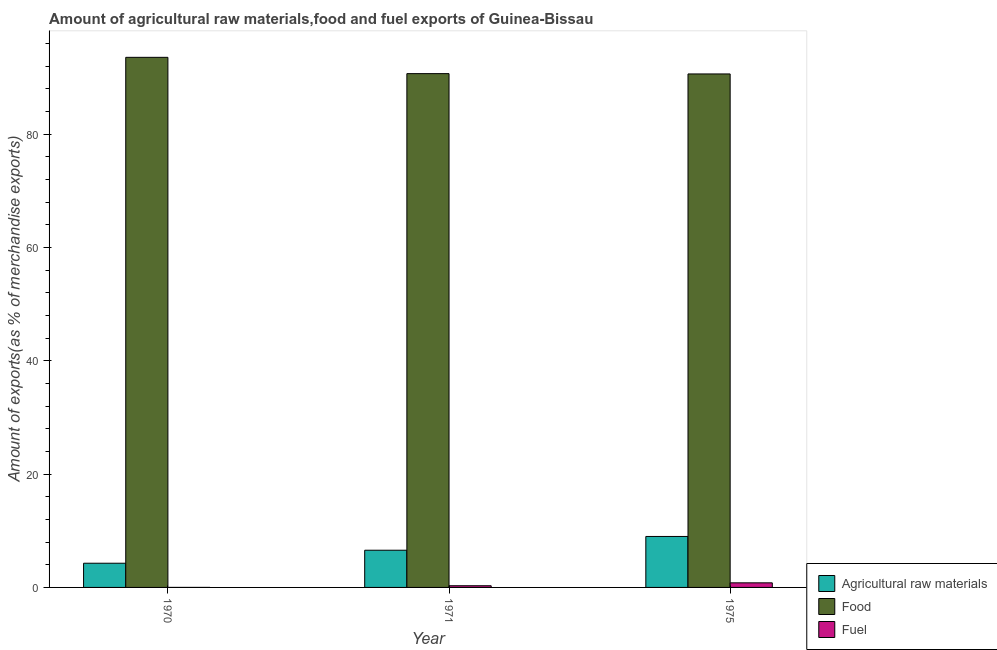How many bars are there on the 1st tick from the right?
Your answer should be very brief. 3. What is the label of the 1st group of bars from the left?
Provide a short and direct response. 1970. In how many cases, is the number of bars for a given year not equal to the number of legend labels?
Keep it short and to the point. 0. What is the percentage of food exports in 1971?
Your response must be concise. 90.71. Across all years, what is the maximum percentage of food exports?
Give a very brief answer. 93.59. Across all years, what is the minimum percentage of food exports?
Give a very brief answer. 90.65. In which year was the percentage of raw materials exports maximum?
Provide a short and direct response. 1975. In which year was the percentage of fuel exports minimum?
Give a very brief answer. 1970. What is the total percentage of fuel exports in the graph?
Your answer should be compact. 1.11. What is the difference between the percentage of raw materials exports in 1970 and that in 1971?
Make the answer very short. -2.29. What is the difference between the percentage of fuel exports in 1975 and the percentage of raw materials exports in 1970?
Ensure brevity in your answer.  0.81. What is the average percentage of food exports per year?
Keep it short and to the point. 91.65. In how many years, is the percentage of food exports greater than 12 %?
Keep it short and to the point. 3. What is the ratio of the percentage of fuel exports in 1970 to that in 1975?
Your answer should be very brief. 0. Is the difference between the percentage of fuel exports in 1970 and 1971 greater than the difference between the percentage of food exports in 1970 and 1971?
Provide a succinct answer. No. What is the difference between the highest and the second highest percentage of food exports?
Ensure brevity in your answer.  2.88. What is the difference between the highest and the lowest percentage of fuel exports?
Ensure brevity in your answer.  0.81. In how many years, is the percentage of raw materials exports greater than the average percentage of raw materials exports taken over all years?
Give a very brief answer. 1. What does the 2nd bar from the left in 1971 represents?
Offer a very short reply. Food. What does the 1st bar from the right in 1971 represents?
Make the answer very short. Fuel. Is it the case that in every year, the sum of the percentage of raw materials exports and percentage of food exports is greater than the percentage of fuel exports?
Your answer should be compact. Yes. How many bars are there?
Offer a very short reply. 9. Are all the bars in the graph horizontal?
Your answer should be very brief. No. What is the difference between two consecutive major ticks on the Y-axis?
Keep it short and to the point. 20. Are the values on the major ticks of Y-axis written in scientific E-notation?
Your answer should be compact. No. Does the graph contain any zero values?
Ensure brevity in your answer.  No. Does the graph contain grids?
Provide a succinct answer. No. Where does the legend appear in the graph?
Your answer should be compact. Bottom right. How many legend labels are there?
Your response must be concise. 3. How are the legend labels stacked?
Your response must be concise. Vertical. What is the title of the graph?
Your answer should be very brief. Amount of agricultural raw materials,food and fuel exports of Guinea-Bissau. What is the label or title of the X-axis?
Provide a succinct answer. Year. What is the label or title of the Y-axis?
Your answer should be very brief. Amount of exports(as % of merchandise exports). What is the Amount of exports(as % of merchandise exports) in Agricultural raw materials in 1970?
Keep it short and to the point. 4.27. What is the Amount of exports(as % of merchandise exports) in Food in 1970?
Offer a terse response. 93.59. What is the Amount of exports(as % of merchandise exports) of Fuel in 1970?
Offer a terse response. 0. What is the Amount of exports(as % of merchandise exports) of Agricultural raw materials in 1971?
Ensure brevity in your answer.  6.57. What is the Amount of exports(as % of merchandise exports) in Food in 1971?
Your answer should be compact. 90.71. What is the Amount of exports(as % of merchandise exports) in Fuel in 1971?
Give a very brief answer. 0.3. What is the Amount of exports(as % of merchandise exports) in Agricultural raw materials in 1975?
Provide a short and direct response. 9. What is the Amount of exports(as % of merchandise exports) in Food in 1975?
Offer a very short reply. 90.65. What is the Amount of exports(as % of merchandise exports) of Fuel in 1975?
Provide a succinct answer. 0.81. Across all years, what is the maximum Amount of exports(as % of merchandise exports) of Agricultural raw materials?
Make the answer very short. 9. Across all years, what is the maximum Amount of exports(as % of merchandise exports) in Food?
Your answer should be compact. 93.59. Across all years, what is the maximum Amount of exports(as % of merchandise exports) of Fuel?
Offer a very short reply. 0.81. Across all years, what is the minimum Amount of exports(as % of merchandise exports) in Agricultural raw materials?
Provide a short and direct response. 4.27. Across all years, what is the minimum Amount of exports(as % of merchandise exports) in Food?
Keep it short and to the point. 90.65. Across all years, what is the minimum Amount of exports(as % of merchandise exports) in Fuel?
Make the answer very short. 0. What is the total Amount of exports(as % of merchandise exports) in Agricultural raw materials in the graph?
Make the answer very short. 19.84. What is the total Amount of exports(as % of merchandise exports) in Food in the graph?
Offer a very short reply. 274.95. What is the total Amount of exports(as % of merchandise exports) in Fuel in the graph?
Provide a short and direct response. 1.11. What is the difference between the Amount of exports(as % of merchandise exports) in Agricultural raw materials in 1970 and that in 1971?
Provide a succinct answer. -2.29. What is the difference between the Amount of exports(as % of merchandise exports) in Food in 1970 and that in 1971?
Your response must be concise. 2.88. What is the difference between the Amount of exports(as % of merchandise exports) of Fuel in 1970 and that in 1971?
Make the answer very short. -0.3. What is the difference between the Amount of exports(as % of merchandise exports) of Agricultural raw materials in 1970 and that in 1975?
Your answer should be compact. -4.73. What is the difference between the Amount of exports(as % of merchandise exports) in Food in 1970 and that in 1975?
Offer a terse response. 2.93. What is the difference between the Amount of exports(as % of merchandise exports) of Fuel in 1970 and that in 1975?
Your answer should be very brief. -0.81. What is the difference between the Amount of exports(as % of merchandise exports) of Agricultural raw materials in 1971 and that in 1975?
Your response must be concise. -2.43. What is the difference between the Amount of exports(as % of merchandise exports) in Food in 1971 and that in 1975?
Keep it short and to the point. 0.06. What is the difference between the Amount of exports(as % of merchandise exports) in Fuel in 1971 and that in 1975?
Make the answer very short. -0.51. What is the difference between the Amount of exports(as % of merchandise exports) in Agricultural raw materials in 1970 and the Amount of exports(as % of merchandise exports) in Food in 1971?
Your answer should be compact. -86.44. What is the difference between the Amount of exports(as % of merchandise exports) of Agricultural raw materials in 1970 and the Amount of exports(as % of merchandise exports) of Fuel in 1971?
Your answer should be compact. 3.97. What is the difference between the Amount of exports(as % of merchandise exports) of Food in 1970 and the Amount of exports(as % of merchandise exports) of Fuel in 1971?
Offer a terse response. 93.29. What is the difference between the Amount of exports(as % of merchandise exports) in Agricultural raw materials in 1970 and the Amount of exports(as % of merchandise exports) in Food in 1975?
Your answer should be compact. -86.38. What is the difference between the Amount of exports(as % of merchandise exports) in Agricultural raw materials in 1970 and the Amount of exports(as % of merchandise exports) in Fuel in 1975?
Provide a succinct answer. 3.46. What is the difference between the Amount of exports(as % of merchandise exports) of Food in 1970 and the Amount of exports(as % of merchandise exports) of Fuel in 1975?
Make the answer very short. 92.78. What is the difference between the Amount of exports(as % of merchandise exports) in Agricultural raw materials in 1971 and the Amount of exports(as % of merchandise exports) in Food in 1975?
Provide a succinct answer. -84.09. What is the difference between the Amount of exports(as % of merchandise exports) of Agricultural raw materials in 1971 and the Amount of exports(as % of merchandise exports) of Fuel in 1975?
Offer a very short reply. 5.76. What is the difference between the Amount of exports(as % of merchandise exports) in Food in 1971 and the Amount of exports(as % of merchandise exports) in Fuel in 1975?
Make the answer very short. 89.9. What is the average Amount of exports(as % of merchandise exports) in Agricultural raw materials per year?
Your answer should be compact. 6.61. What is the average Amount of exports(as % of merchandise exports) in Food per year?
Your answer should be compact. 91.65. What is the average Amount of exports(as % of merchandise exports) of Fuel per year?
Offer a terse response. 0.37. In the year 1970, what is the difference between the Amount of exports(as % of merchandise exports) of Agricultural raw materials and Amount of exports(as % of merchandise exports) of Food?
Your answer should be compact. -89.32. In the year 1970, what is the difference between the Amount of exports(as % of merchandise exports) of Agricultural raw materials and Amount of exports(as % of merchandise exports) of Fuel?
Give a very brief answer. 4.27. In the year 1970, what is the difference between the Amount of exports(as % of merchandise exports) in Food and Amount of exports(as % of merchandise exports) in Fuel?
Give a very brief answer. 93.58. In the year 1971, what is the difference between the Amount of exports(as % of merchandise exports) in Agricultural raw materials and Amount of exports(as % of merchandise exports) in Food?
Your answer should be very brief. -84.14. In the year 1971, what is the difference between the Amount of exports(as % of merchandise exports) of Agricultural raw materials and Amount of exports(as % of merchandise exports) of Fuel?
Keep it short and to the point. 6.27. In the year 1971, what is the difference between the Amount of exports(as % of merchandise exports) in Food and Amount of exports(as % of merchandise exports) in Fuel?
Your answer should be compact. 90.41. In the year 1975, what is the difference between the Amount of exports(as % of merchandise exports) in Agricultural raw materials and Amount of exports(as % of merchandise exports) in Food?
Your answer should be very brief. -81.66. In the year 1975, what is the difference between the Amount of exports(as % of merchandise exports) of Agricultural raw materials and Amount of exports(as % of merchandise exports) of Fuel?
Your answer should be very brief. 8.19. In the year 1975, what is the difference between the Amount of exports(as % of merchandise exports) of Food and Amount of exports(as % of merchandise exports) of Fuel?
Make the answer very short. 89.84. What is the ratio of the Amount of exports(as % of merchandise exports) of Agricultural raw materials in 1970 to that in 1971?
Your answer should be very brief. 0.65. What is the ratio of the Amount of exports(as % of merchandise exports) in Food in 1970 to that in 1971?
Provide a short and direct response. 1.03. What is the ratio of the Amount of exports(as % of merchandise exports) in Fuel in 1970 to that in 1971?
Your answer should be very brief. 0.01. What is the ratio of the Amount of exports(as % of merchandise exports) in Agricultural raw materials in 1970 to that in 1975?
Make the answer very short. 0.47. What is the ratio of the Amount of exports(as % of merchandise exports) in Food in 1970 to that in 1975?
Your response must be concise. 1.03. What is the ratio of the Amount of exports(as % of merchandise exports) of Fuel in 1970 to that in 1975?
Offer a very short reply. 0. What is the ratio of the Amount of exports(as % of merchandise exports) in Agricultural raw materials in 1971 to that in 1975?
Make the answer very short. 0.73. What is the ratio of the Amount of exports(as % of merchandise exports) in Food in 1971 to that in 1975?
Your response must be concise. 1. What is the ratio of the Amount of exports(as % of merchandise exports) in Fuel in 1971 to that in 1975?
Ensure brevity in your answer.  0.37. What is the difference between the highest and the second highest Amount of exports(as % of merchandise exports) in Agricultural raw materials?
Your response must be concise. 2.43. What is the difference between the highest and the second highest Amount of exports(as % of merchandise exports) in Food?
Offer a very short reply. 2.88. What is the difference between the highest and the second highest Amount of exports(as % of merchandise exports) of Fuel?
Keep it short and to the point. 0.51. What is the difference between the highest and the lowest Amount of exports(as % of merchandise exports) in Agricultural raw materials?
Give a very brief answer. 4.73. What is the difference between the highest and the lowest Amount of exports(as % of merchandise exports) of Food?
Give a very brief answer. 2.93. What is the difference between the highest and the lowest Amount of exports(as % of merchandise exports) of Fuel?
Ensure brevity in your answer.  0.81. 